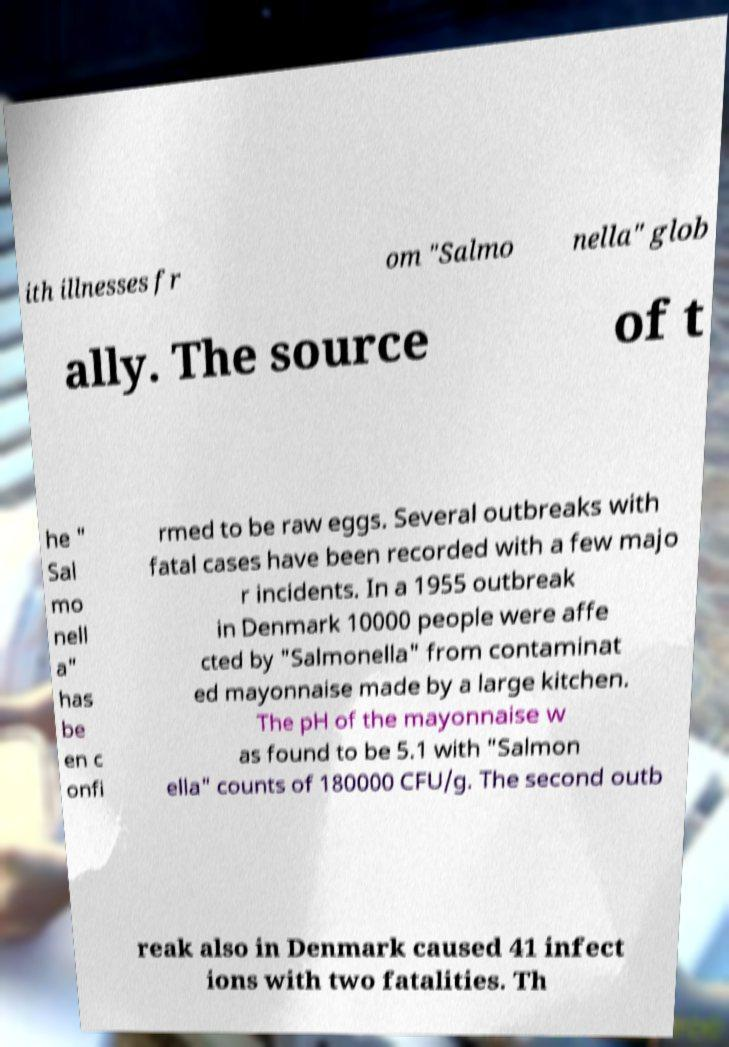Could you assist in decoding the text presented in this image and type it out clearly? ith illnesses fr om "Salmo nella" glob ally. The source of t he " Sal mo nell a" has be en c onfi rmed to be raw eggs. Several outbreaks with fatal cases have been recorded with a few majo r incidents. In a 1955 outbreak in Denmark 10000 people were affe cted by "Salmonella" from contaminat ed mayonnaise made by a large kitchen. The pH of the mayonnaise w as found to be 5.1 with "Salmon ella" counts of 180000 CFU/g. The second outb reak also in Denmark caused 41 infect ions with two fatalities. Th 